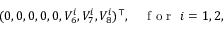<formula> <loc_0><loc_0><loc_500><loc_500>\begin{array} { r } { ( 0 , 0 , 0 , 0 , 0 , V _ { 6 } ^ { i } , V _ { 7 } ^ { i } , V _ { 8 } ^ { i } ) ^ { \top } , \quad f o r i = 1 , 2 , } \end{array}</formula> 